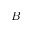Convert formula to latex. <formula><loc_0><loc_0><loc_500><loc_500>B</formula> 